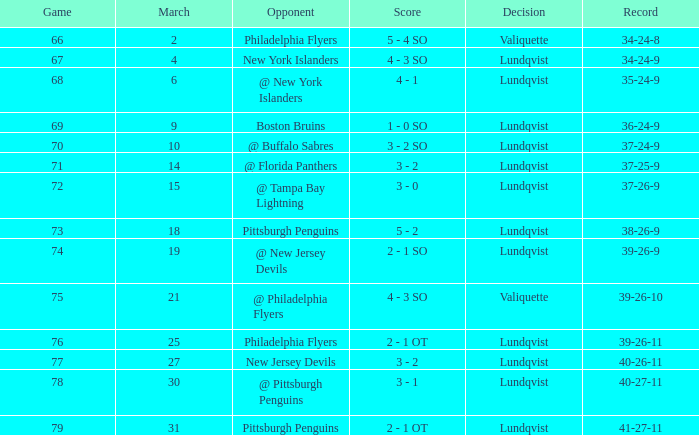In which match was the score under 69 when the march was greater than 2 and the opponents were the new york islanders? 4 - 3 SO. 